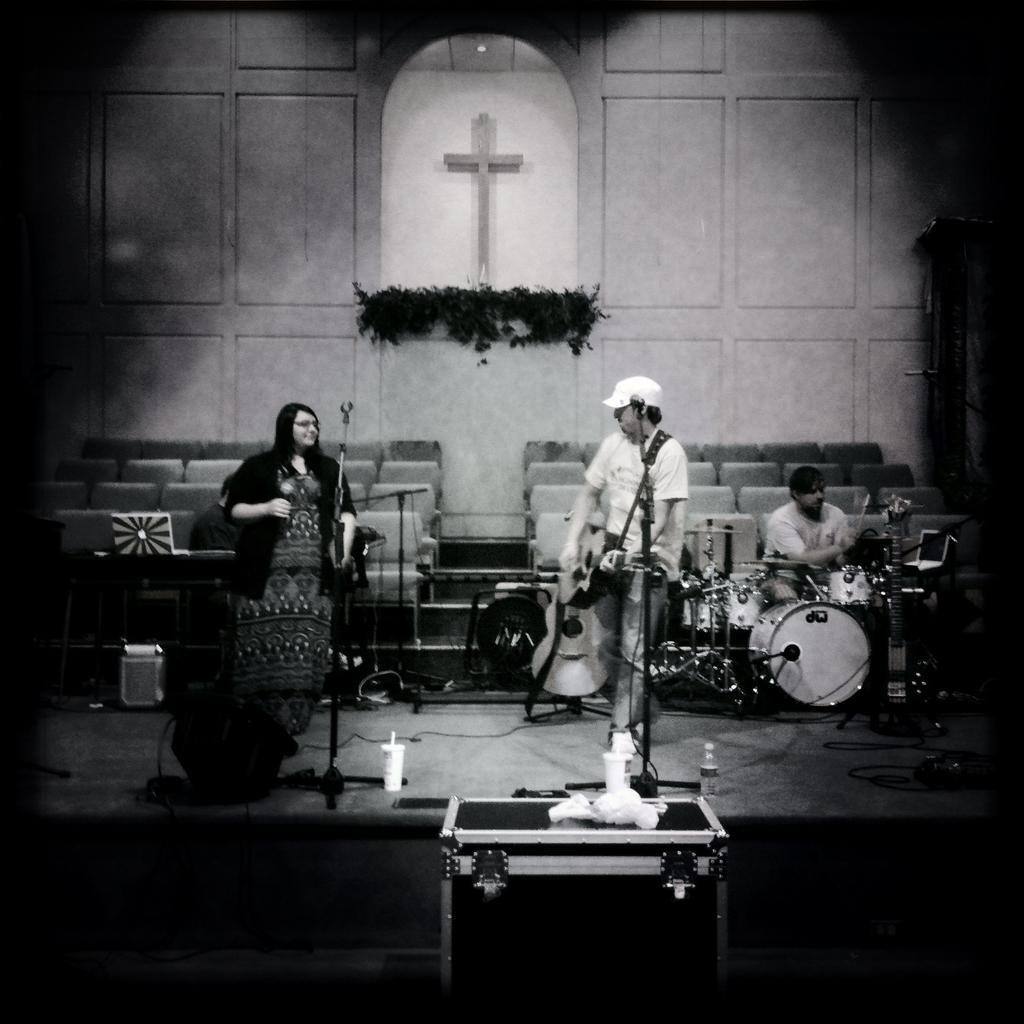Could you give a brief overview of what you see in this image? In this picture we can see three persons, a person in the middle is playing a guitar, a person on the right side is playing drums, there are microphones, musical instruments and chairs in the middle, in the background there are leaves and a wall, we can see a box, glasses and a bottle in the front, it is a black and white image. 